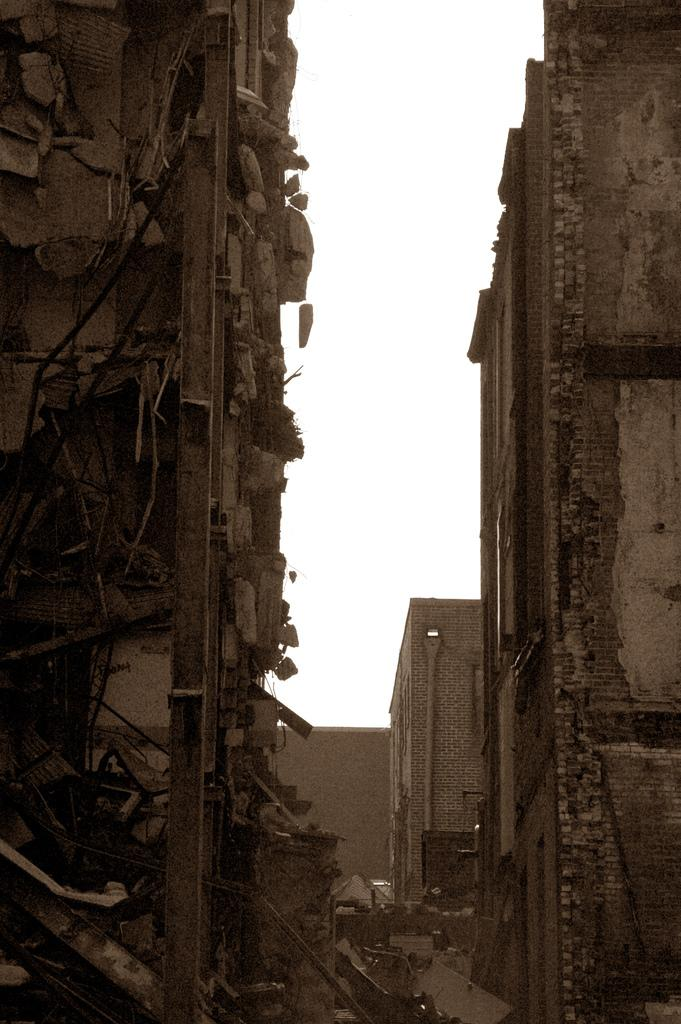What type of structures can be seen in the image? There are buildings in the image. What else can be seen in the image besides the buildings? There are wires visible in the image. Where are the metal objects located in the image? The metal objects are on the left side of the image. What type of pan is being used by the spy in the image? There is no pan or spy present in the image. What color is the sky in the image? The provided facts do not mention the color of the sky, so we cannot determine its color from the image. 